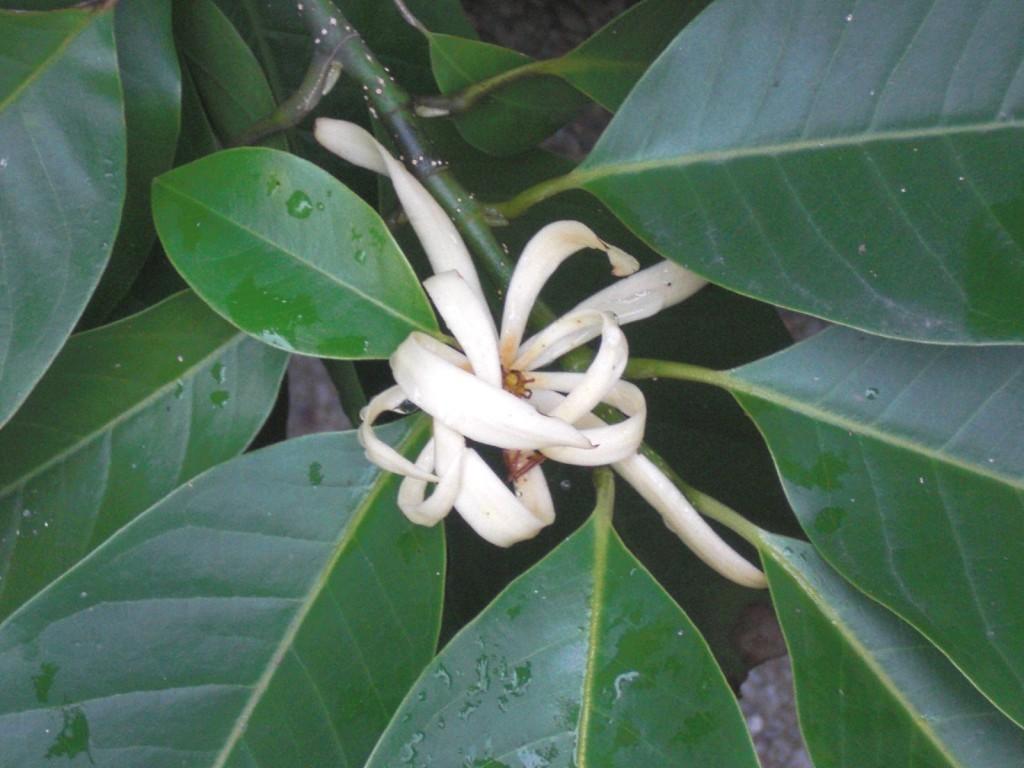Can you describe this image briefly? In this image we can see there is a flower and leaves. 